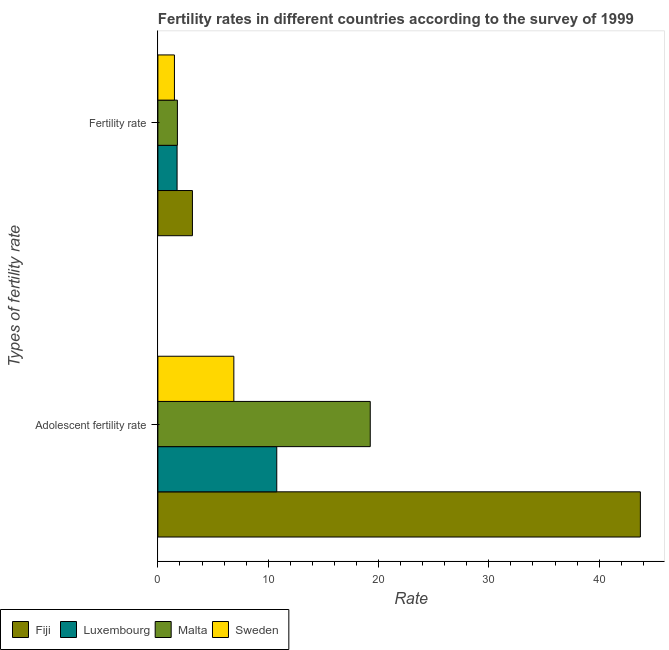How many groups of bars are there?
Offer a terse response. 2. How many bars are there on the 2nd tick from the top?
Provide a succinct answer. 4. What is the label of the 2nd group of bars from the top?
Offer a terse response. Adolescent fertility rate. What is the fertility rate in Luxembourg?
Your answer should be very brief. 1.74. Across all countries, what is the maximum adolescent fertility rate?
Keep it short and to the point. 43.74. In which country was the fertility rate maximum?
Ensure brevity in your answer.  Fiji. In which country was the fertility rate minimum?
Ensure brevity in your answer.  Sweden. What is the total fertility rate in the graph?
Your answer should be compact. 8.14. What is the difference between the fertility rate in Fiji and that in Malta?
Your response must be concise. 1.36. What is the difference between the adolescent fertility rate in Malta and the fertility rate in Luxembourg?
Ensure brevity in your answer.  17.51. What is the average adolescent fertility rate per country?
Ensure brevity in your answer.  20.16. What is the difference between the adolescent fertility rate and fertility rate in Luxembourg?
Your answer should be compact. 9.04. In how many countries, is the fertility rate greater than 24 ?
Offer a very short reply. 0. What is the ratio of the adolescent fertility rate in Luxembourg to that in Sweden?
Keep it short and to the point. 1.57. Is the adolescent fertility rate in Malta less than that in Sweden?
Your answer should be very brief. No. In how many countries, is the adolescent fertility rate greater than the average adolescent fertility rate taken over all countries?
Keep it short and to the point. 1. What does the 2nd bar from the top in Adolescent fertility rate represents?
Ensure brevity in your answer.  Malta. What does the 2nd bar from the bottom in Fertility rate represents?
Offer a terse response. Luxembourg. Are all the bars in the graph horizontal?
Provide a succinct answer. Yes. What is the difference between two consecutive major ticks on the X-axis?
Offer a very short reply. 10. Are the values on the major ticks of X-axis written in scientific E-notation?
Provide a short and direct response. No. Does the graph contain grids?
Provide a succinct answer. No. Where does the legend appear in the graph?
Your answer should be very brief. Bottom left. What is the title of the graph?
Your answer should be very brief. Fertility rates in different countries according to the survey of 1999. What is the label or title of the X-axis?
Your answer should be compact. Rate. What is the label or title of the Y-axis?
Give a very brief answer. Types of fertility rate. What is the Rate in Fiji in Adolescent fertility rate?
Your response must be concise. 43.74. What is the Rate in Luxembourg in Adolescent fertility rate?
Offer a very short reply. 10.78. What is the Rate in Malta in Adolescent fertility rate?
Make the answer very short. 19.25. What is the Rate of Sweden in Adolescent fertility rate?
Make the answer very short. 6.89. What is the Rate of Fiji in Fertility rate?
Provide a succinct answer. 3.13. What is the Rate of Luxembourg in Fertility rate?
Offer a terse response. 1.74. What is the Rate in Malta in Fertility rate?
Provide a short and direct response. 1.77. Across all Types of fertility rate, what is the maximum Rate of Fiji?
Provide a short and direct response. 43.74. Across all Types of fertility rate, what is the maximum Rate of Luxembourg?
Provide a succinct answer. 10.78. Across all Types of fertility rate, what is the maximum Rate of Malta?
Provide a short and direct response. 19.25. Across all Types of fertility rate, what is the maximum Rate in Sweden?
Your response must be concise. 6.89. Across all Types of fertility rate, what is the minimum Rate in Fiji?
Make the answer very short. 3.13. Across all Types of fertility rate, what is the minimum Rate in Luxembourg?
Your response must be concise. 1.74. Across all Types of fertility rate, what is the minimum Rate in Malta?
Your answer should be compact. 1.77. Across all Types of fertility rate, what is the minimum Rate in Sweden?
Offer a terse response. 1.5. What is the total Rate in Fiji in the graph?
Offer a terse response. 46.87. What is the total Rate in Luxembourg in the graph?
Your response must be concise. 12.52. What is the total Rate in Malta in the graph?
Your response must be concise. 21.02. What is the total Rate of Sweden in the graph?
Provide a short and direct response. 8.39. What is the difference between the Rate in Fiji in Adolescent fertility rate and that in Fertility rate?
Make the answer very short. 40.6. What is the difference between the Rate of Luxembourg in Adolescent fertility rate and that in Fertility rate?
Provide a succinct answer. 9.04. What is the difference between the Rate in Malta in Adolescent fertility rate and that in Fertility rate?
Make the answer very short. 17.48. What is the difference between the Rate of Sweden in Adolescent fertility rate and that in Fertility rate?
Your answer should be very brief. 5.39. What is the difference between the Rate of Fiji in Adolescent fertility rate and the Rate of Luxembourg in Fertility rate?
Offer a very short reply. 42. What is the difference between the Rate of Fiji in Adolescent fertility rate and the Rate of Malta in Fertility rate?
Keep it short and to the point. 41.97. What is the difference between the Rate in Fiji in Adolescent fertility rate and the Rate in Sweden in Fertility rate?
Give a very brief answer. 42.24. What is the difference between the Rate of Luxembourg in Adolescent fertility rate and the Rate of Malta in Fertility rate?
Your answer should be very brief. 9.01. What is the difference between the Rate of Luxembourg in Adolescent fertility rate and the Rate of Sweden in Fertility rate?
Your answer should be compact. 9.28. What is the difference between the Rate in Malta in Adolescent fertility rate and the Rate in Sweden in Fertility rate?
Keep it short and to the point. 17.75. What is the average Rate in Fiji per Types of fertility rate?
Keep it short and to the point. 23.43. What is the average Rate of Luxembourg per Types of fertility rate?
Make the answer very short. 6.26. What is the average Rate in Malta per Types of fertility rate?
Keep it short and to the point. 10.51. What is the average Rate in Sweden per Types of fertility rate?
Keep it short and to the point. 4.19. What is the difference between the Rate in Fiji and Rate in Luxembourg in Adolescent fertility rate?
Your answer should be very brief. 32.96. What is the difference between the Rate of Fiji and Rate of Malta in Adolescent fertility rate?
Keep it short and to the point. 24.49. What is the difference between the Rate of Fiji and Rate of Sweden in Adolescent fertility rate?
Ensure brevity in your answer.  36.85. What is the difference between the Rate in Luxembourg and Rate in Malta in Adolescent fertility rate?
Your response must be concise. -8.48. What is the difference between the Rate of Luxembourg and Rate of Sweden in Adolescent fertility rate?
Offer a very short reply. 3.89. What is the difference between the Rate in Malta and Rate in Sweden in Adolescent fertility rate?
Give a very brief answer. 12.37. What is the difference between the Rate in Fiji and Rate in Luxembourg in Fertility rate?
Offer a very short reply. 1.39. What is the difference between the Rate in Fiji and Rate in Malta in Fertility rate?
Offer a terse response. 1.36. What is the difference between the Rate of Fiji and Rate of Sweden in Fertility rate?
Your answer should be very brief. 1.63. What is the difference between the Rate in Luxembourg and Rate in Malta in Fertility rate?
Give a very brief answer. -0.03. What is the difference between the Rate of Luxembourg and Rate of Sweden in Fertility rate?
Give a very brief answer. 0.24. What is the difference between the Rate in Malta and Rate in Sweden in Fertility rate?
Give a very brief answer. 0.27. What is the ratio of the Rate in Fiji in Adolescent fertility rate to that in Fertility rate?
Your answer should be very brief. 13.96. What is the ratio of the Rate in Luxembourg in Adolescent fertility rate to that in Fertility rate?
Keep it short and to the point. 6.19. What is the ratio of the Rate of Malta in Adolescent fertility rate to that in Fertility rate?
Provide a short and direct response. 10.88. What is the ratio of the Rate in Sweden in Adolescent fertility rate to that in Fertility rate?
Keep it short and to the point. 4.59. What is the difference between the highest and the second highest Rate in Fiji?
Give a very brief answer. 40.6. What is the difference between the highest and the second highest Rate of Luxembourg?
Your response must be concise. 9.04. What is the difference between the highest and the second highest Rate of Malta?
Give a very brief answer. 17.48. What is the difference between the highest and the second highest Rate in Sweden?
Your answer should be compact. 5.39. What is the difference between the highest and the lowest Rate in Fiji?
Provide a short and direct response. 40.6. What is the difference between the highest and the lowest Rate of Luxembourg?
Ensure brevity in your answer.  9.04. What is the difference between the highest and the lowest Rate in Malta?
Your response must be concise. 17.48. What is the difference between the highest and the lowest Rate in Sweden?
Offer a terse response. 5.39. 